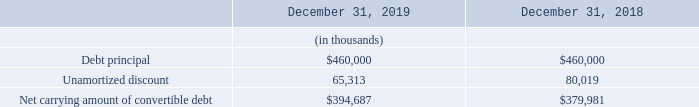The below tables represents the key components of Teradyne’s convertible senior notes:
As of December 31, 2019, the unamortized discount was $65.3 million, which will be amortized over four years using the effective interest rate method. The carrying amount of the equity component was $100.8 million. As of December 31, 2019, the conversion price was approximately $31.62 per share and if converted the value of the notes was $992.0 million.
What was the unamortized discount in 2019? $65.3 million. What was the carrying amount of the equity component? $100.8 million. What were the key components of Teradyne’s convertible senior notes in the table? Debt principal, unamortized discount, net carrying amount of convertible debt. In which year was the amount of Unamortized discount larger? 80,019>65,313
Answer: 2018. What was the change in Debt principal from 2018 to 2019?
Answer scale should be: thousand. 460,000-460,000
Answer: 0. What was the percentage change in Debt principal from 2018 to 2019?
Answer scale should be: percent. (460,000-460,000)/460,000
Answer: 0. 